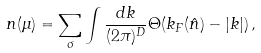Convert formula to latex. <formula><loc_0><loc_0><loc_500><loc_500>n ( \mu ) = \sum _ { \sigma } \int \frac { d { k } } { ( 2 \pi ) ^ { D } } \Theta ( k _ { F } ( \hat { n } ) - | { k } | ) \, ,</formula> 